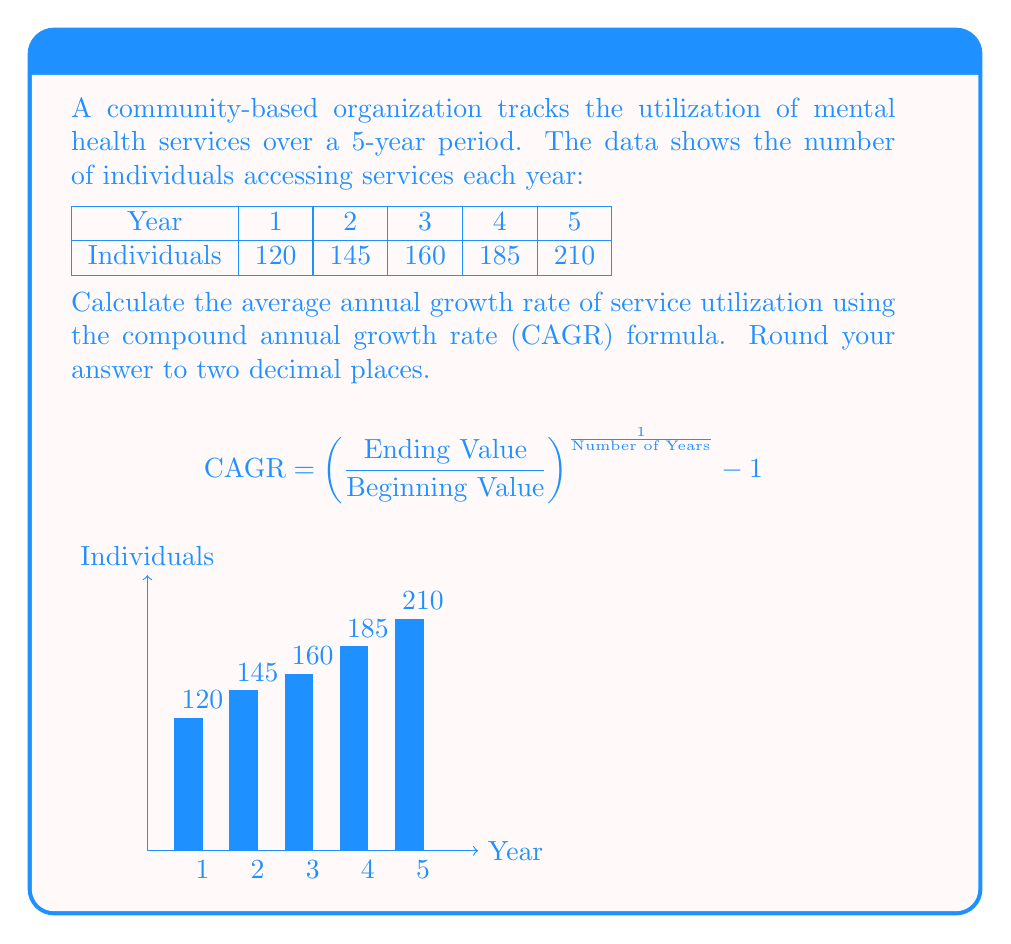Teach me how to tackle this problem. To calculate the Compound Annual Growth Rate (CAGR), we'll follow these steps:

1. Identify the beginning value (Year 1) and ending value (Year 5):
   Beginning Value = 120
   Ending Value = 210

2. Determine the number of years: 5

3. Apply the CAGR formula:

   $$\text{CAGR} = \left(\frac{\text{Ending Value}}{\text{Beginning Value}}\right)^{\frac{1}{\text{Number of Years}}} - 1$$

   $$\text{CAGR} = \left(\frac{210}{120}\right)^{\frac{1}{5}} - 1$$

4. Calculate the value inside the parentheses:
   $$\text{CAGR} = (1.75)^{\frac{1}{5}} - 1$$

5. Calculate the fifth root:
   $$\text{CAGR} = 1.1183 - 1$$

6. Subtract 1:
   $$\text{CAGR} = 0.1183$$

7. Convert to percentage and round to two decimal places:
   $$\text{CAGR} = 11.83\%$$

Therefore, the average annual growth rate of service utilization is 11.83%.
Answer: 11.83% 